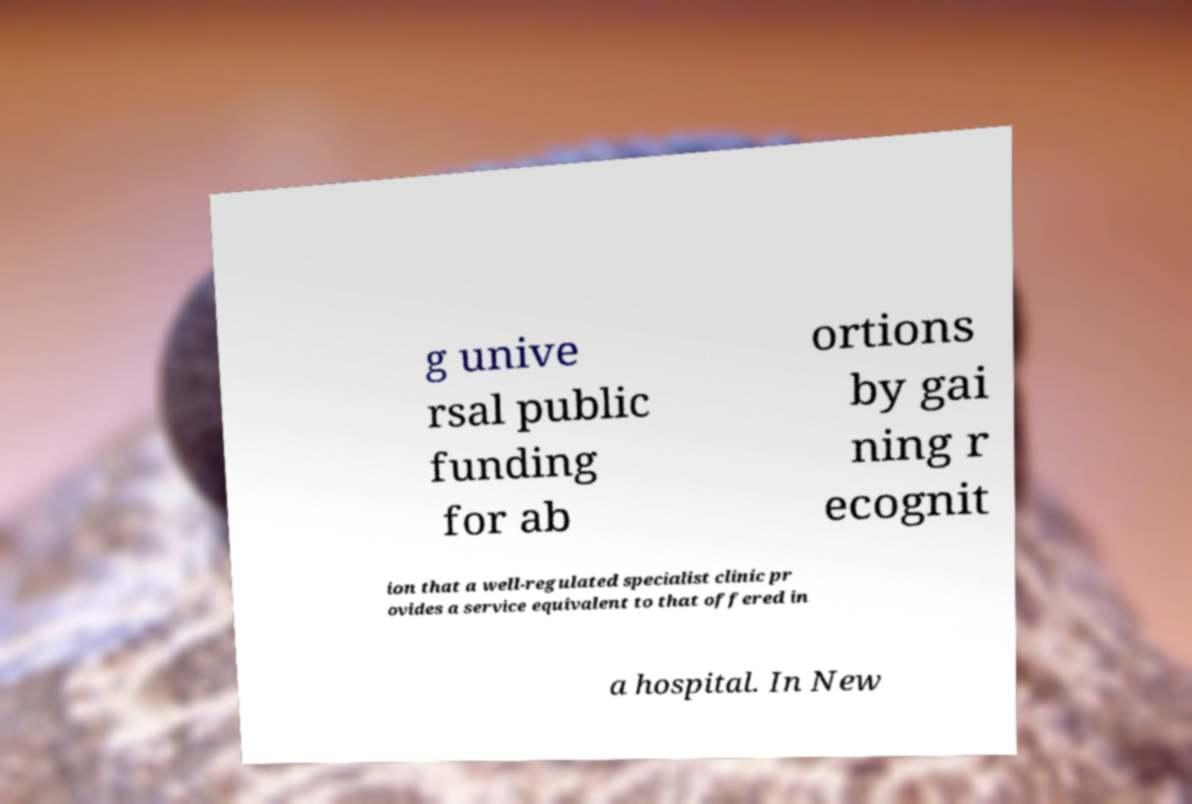Could you extract and type out the text from this image? g unive rsal public funding for ab ortions by gai ning r ecognit ion that a well-regulated specialist clinic pr ovides a service equivalent to that offered in a hospital. In New 